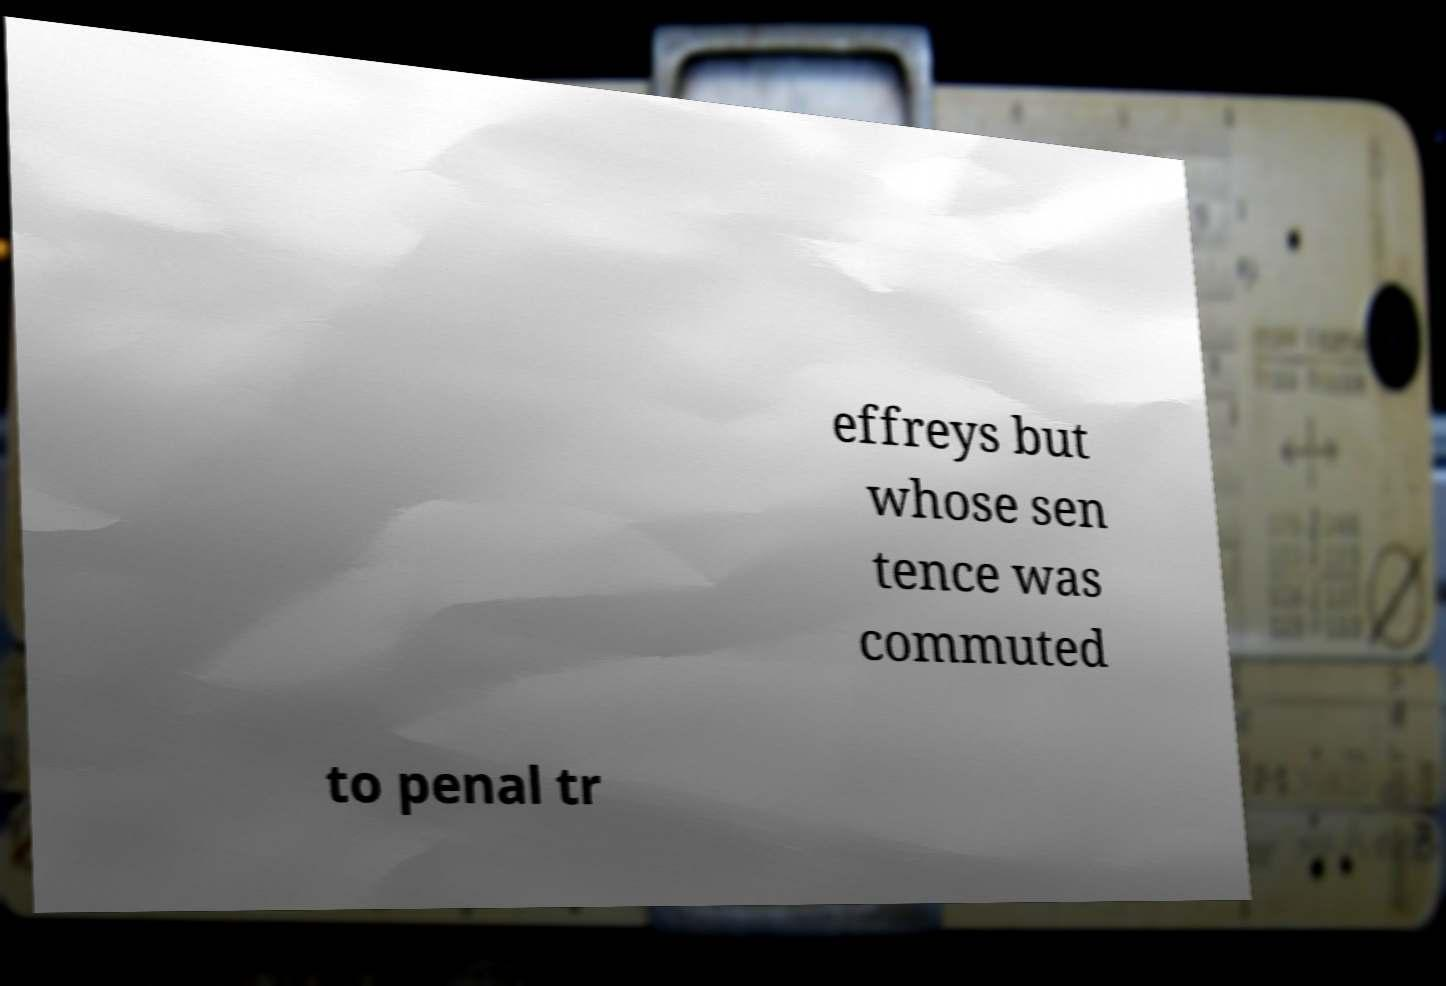I need the written content from this picture converted into text. Can you do that? effreys but whose sen tence was commuted to penal tr 